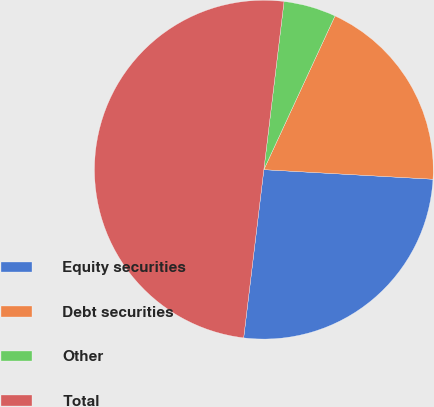Convert chart to OTSL. <chart><loc_0><loc_0><loc_500><loc_500><pie_chart><fcel>Equity securities<fcel>Debt securities<fcel>Other<fcel>Total<nl><fcel>26.0%<fcel>19.0%<fcel>5.0%<fcel>50.0%<nl></chart> 